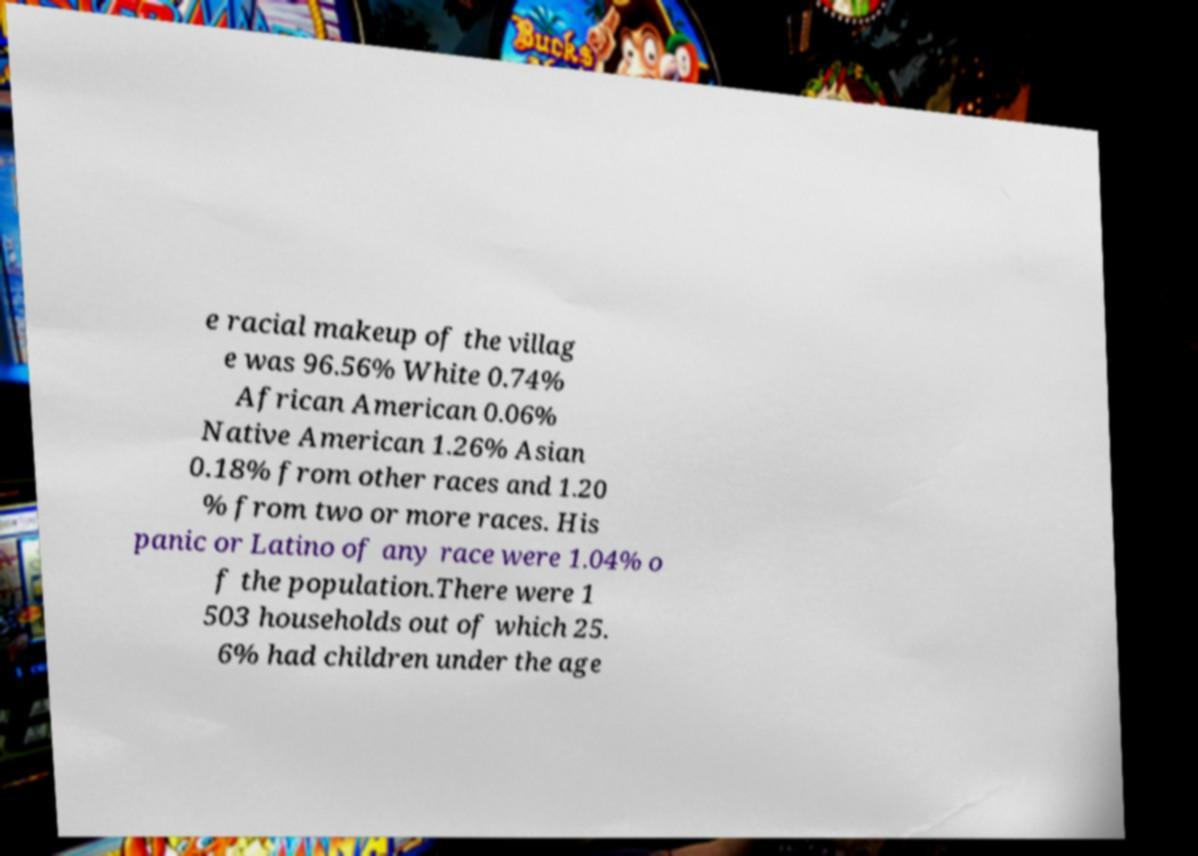Can you read and provide the text displayed in the image?This photo seems to have some interesting text. Can you extract and type it out for me? e racial makeup of the villag e was 96.56% White 0.74% African American 0.06% Native American 1.26% Asian 0.18% from other races and 1.20 % from two or more races. His panic or Latino of any race were 1.04% o f the population.There were 1 503 households out of which 25. 6% had children under the age 